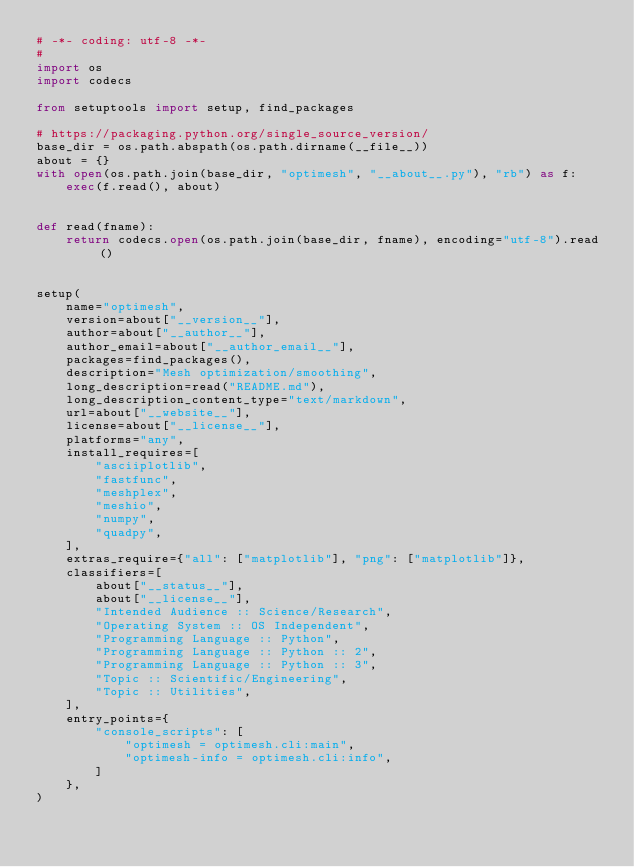Convert code to text. <code><loc_0><loc_0><loc_500><loc_500><_Python_># -*- coding: utf-8 -*-
#
import os
import codecs

from setuptools import setup, find_packages

# https://packaging.python.org/single_source_version/
base_dir = os.path.abspath(os.path.dirname(__file__))
about = {}
with open(os.path.join(base_dir, "optimesh", "__about__.py"), "rb") as f:
    exec(f.read(), about)


def read(fname):
    return codecs.open(os.path.join(base_dir, fname), encoding="utf-8").read()


setup(
    name="optimesh",
    version=about["__version__"],
    author=about["__author__"],
    author_email=about["__author_email__"],
    packages=find_packages(),
    description="Mesh optimization/smoothing",
    long_description=read("README.md"),
    long_description_content_type="text/markdown",
    url=about["__website__"],
    license=about["__license__"],
    platforms="any",
    install_requires=[
        "asciiplotlib",
        "fastfunc",
        "meshplex",
        "meshio",
        "numpy",
        "quadpy",
    ],
    extras_require={"all": ["matplotlib"], "png": ["matplotlib"]},
    classifiers=[
        about["__status__"],
        about["__license__"],
        "Intended Audience :: Science/Research",
        "Operating System :: OS Independent",
        "Programming Language :: Python",
        "Programming Language :: Python :: 2",
        "Programming Language :: Python :: 3",
        "Topic :: Scientific/Engineering",
        "Topic :: Utilities",
    ],
    entry_points={
        "console_scripts": [
            "optimesh = optimesh.cli:main",
            "optimesh-info = optimesh.cli:info",
        ]
    },
)
</code> 